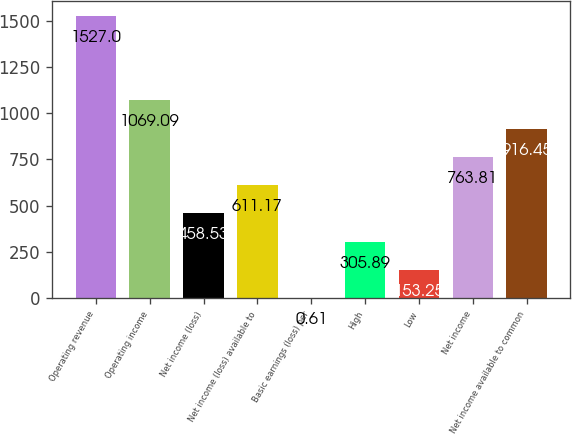Convert chart to OTSL. <chart><loc_0><loc_0><loc_500><loc_500><bar_chart><fcel>Operating revenue<fcel>Operating income<fcel>Net income (loss)<fcel>Net income (loss) available to<fcel>Basic earnings (loss) per<fcel>High<fcel>Low<fcel>Net income<fcel>Net income available to common<nl><fcel>1527<fcel>1069.09<fcel>458.53<fcel>611.17<fcel>0.61<fcel>305.89<fcel>153.25<fcel>763.81<fcel>916.45<nl></chart> 